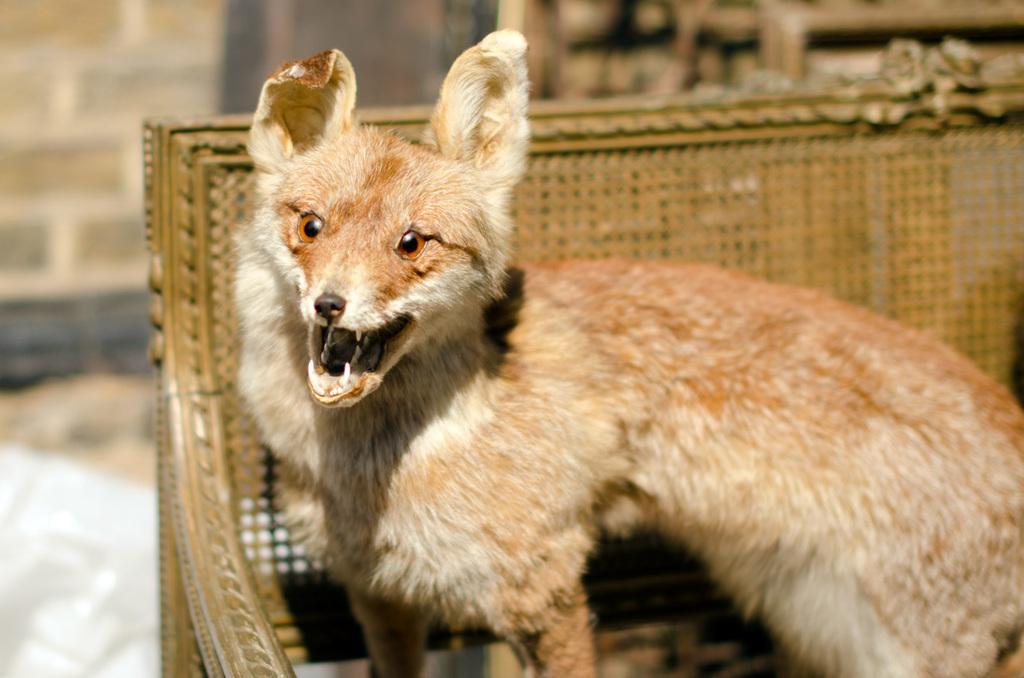Could you give a brief overview of what you see in this image? In this image I can see an animal standing on the bench and the animal is in brown and cream color and the bench is in cream color, and I can see blurred background. 